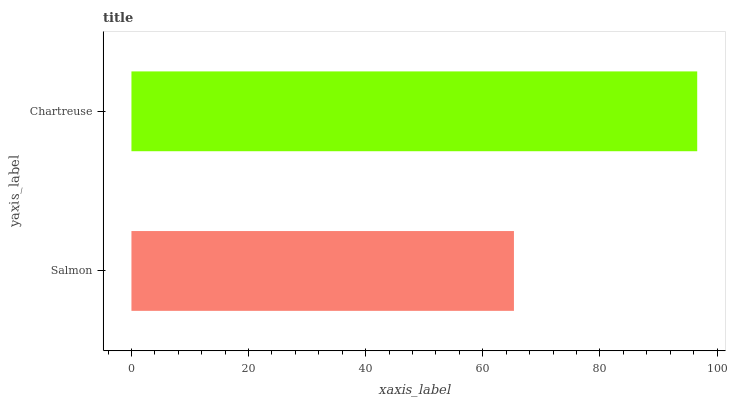Is Salmon the minimum?
Answer yes or no. Yes. Is Chartreuse the maximum?
Answer yes or no. Yes. Is Chartreuse the minimum?
Answer yes or no. No. Is Chartreuse greater than Salmon?
Answer yes or no. Yes. Is Salmon less than Chartreuse?
Answer yes or no. Yes. Is Salmon greater than Chartreuse?
Answer yes or no. No. Is Chartreuse less than Salmon?
Answer yes or no. No. Is Chartreuse the high median?
Answer yes or no. Yes. Is Salmon the low median?
Answer yes or no. Yes. Is Salmon the high median?
Answer yes or no. No. Is Chartreuse the low median?
Answer yes or no. No. 